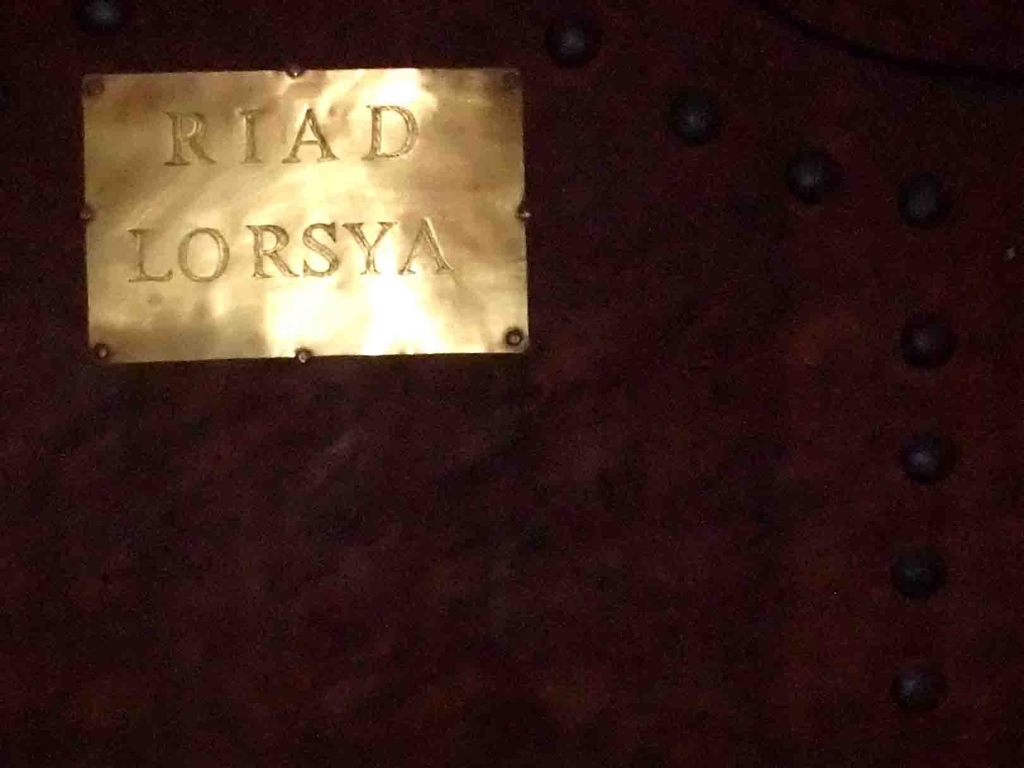Assuming this is an accommodation, what kind of guests might be attracted to Riad Lorsya? Guests who are likely to be attracted to Riad Lorsya would be those seeking an authentic travel experience in Morocco, valuing tradition, craftsmanship, and the local culture's richness. The establishment probably caters to individuals looking for a comfortable yet immersive stay, possibly offering traditional Moroccan meals, hospitality, and an ambience that is reflective of the country's historical and architectural heritage. 